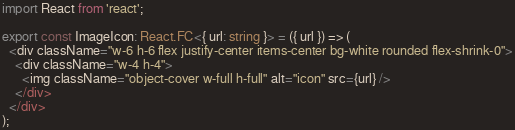<code> <loc_0><loc_0><loc_500><loc_500><_TypeScript_>import React from 'react';

export const ImageIcon: React.FC<{ url: string }> = ({ url }) => (
  <div className="w-6 h-6 flex justify-center items-center bg-white rounded flex-shrink-0">
    <div className="w-4 h-4">
      <img className="object-cover w-full h-full" alt="icon" src={url} />
    </div>
  </div>
);
</code> 